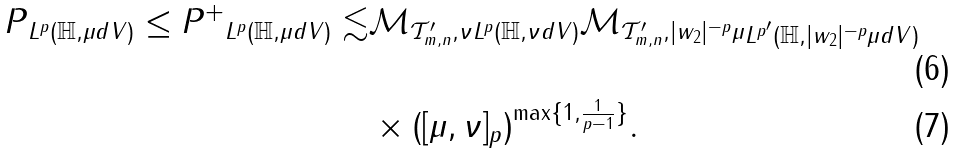Convert formula to latex. <formula><loc_0><loc_0><loc_500><loc_500>\| P \| _ { L ^ { p } ( \mathbb { H } , \mu d V ) } \leq \| P ^ { + } \| _ { L ^ { p } ( \mathbb { H } , \mu d V ) } \lesssim & \| \mathcal { M } _ { \mathcal { T } ^ { \prime } _ { m , n } , \nu } \| _ { L ^ { p } ( \mathbb { H } , \nu d V ) } \| \mathcal { M } _ { \mathcal { T } ^ { \prime } _ { m , n } , | w _ { 2 } | ^ { - p } \mu } \| _ { L ^ { p ^ { \prime } } ( \mathbb { H } , | w _ { 2 } | ^ { - p } \mu d V ) } \\ & \times ( [ \mu , \nu ] _ { p } ) ^ { \max \{ 1 , \frac { 1 } { p - 1 } \} } .</formula> 